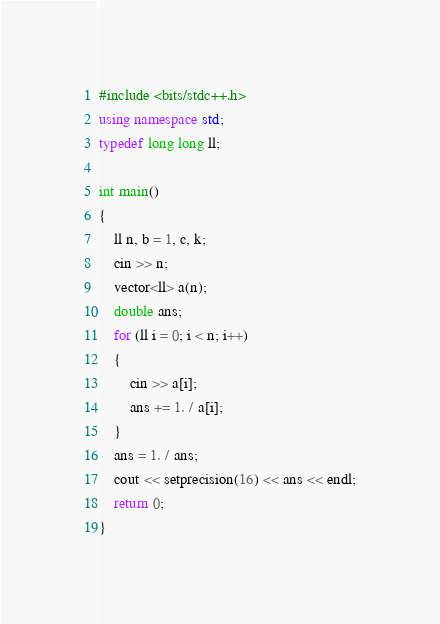Convert code to text. <code><loc_0><loc_0><loc_500><loc_500><_C++_>#include <bits/stdc++.h>
using namespace std;
typedef long long ll;

int main()
{
    ll n, b = 1, c, k;
    cin >> n;
    vector<ll> a(n);
    double ans;
    for (ll i = 0; i < n; i++)
    {
        cin >> a[i];
        ans += 1. / a[i];
    }
    ans = 1. / ans;
    cout << setprecision(16) << ans << endl;
    return 0;
}</code> 